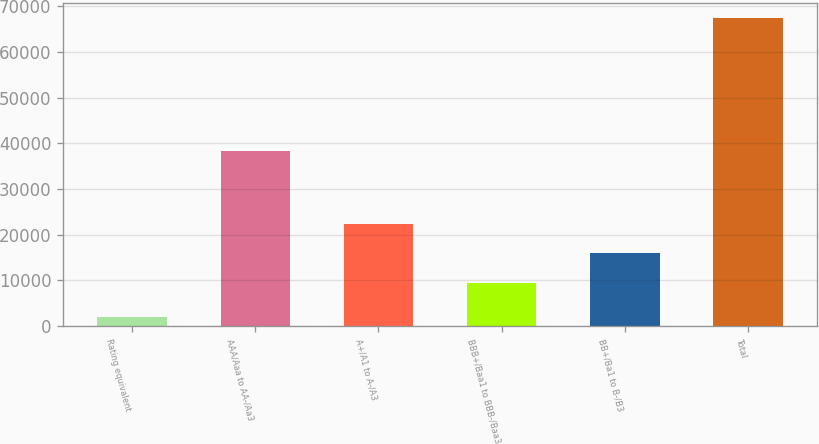<chart> <loc_0><loc_0><loc_500><loc_500><bar_chart><fcel>Rating equivalent<fcel>AAA/Aaa to AA-/Aa3<fcel>A+/A1 to A-/A3<fcel>BBB+/Baa1 to BBB-/Baa3<fcel>BB+/Ba1 to B-/B3<fcel>Total<nl><fcel>2007<fcel>38314<fcel>22396<fcel>9335<fcel>15865.5<fcel>67312<nl></chart> 